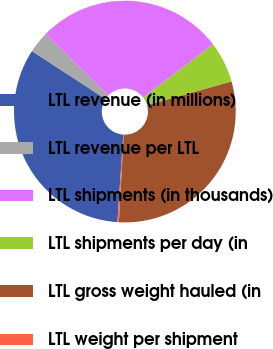<chart> <loc_0><loc_0><loc_500><loc_500><pie_chart><fcel>LTL revenue (in millions)<fcel>LTL revenue per LTL<fcel>LTL shipments (in thousands)<fcel>LTL shipments per day (in<fcel>LTL gross weight hauled (in<fcel>LTL weight per shipment<nl><fcel>33.11%<fcel>3.11%<fcel>27.34%<fcel>5.99%<fcel>30.22%<fcel>0.22%<nl></chart> 